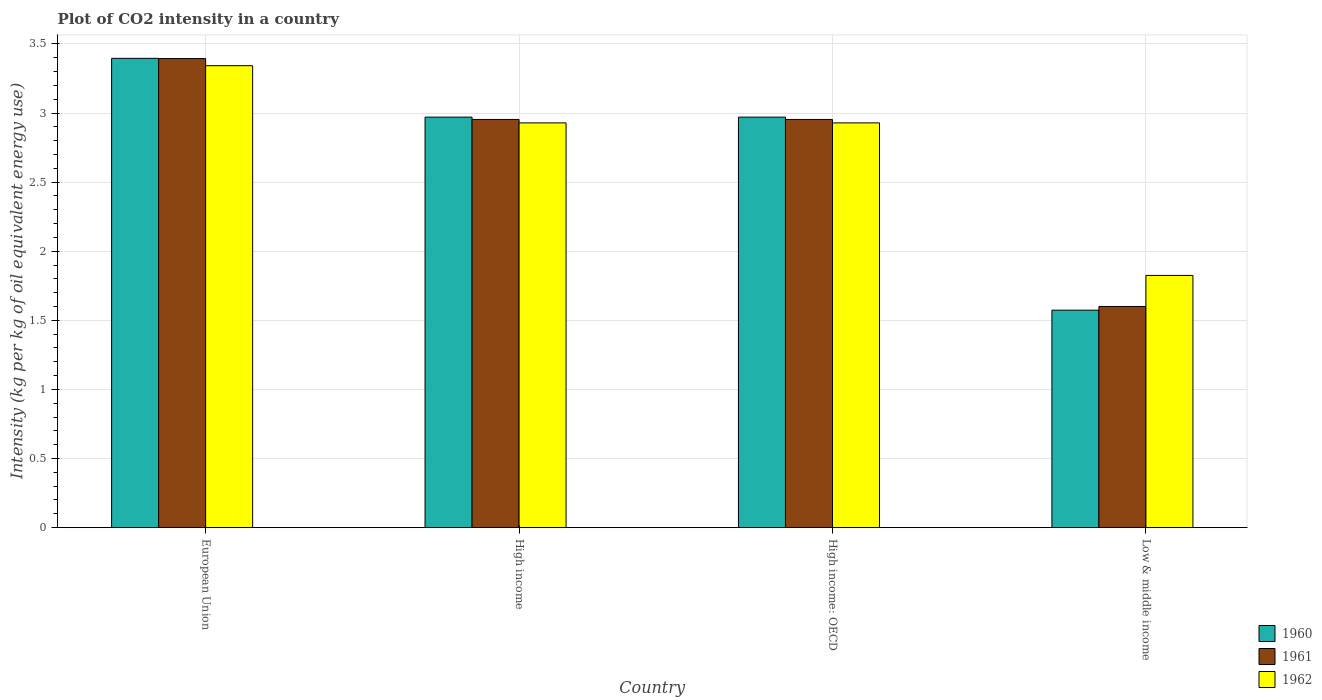How many groups of bars are there?
Your answer should be compact. 4. Are the number of bars per tick equal to the number of legend labels?
Offer a terse response. Yes. Are the number of bars on each tick of the X-axis equal?
Provide a short and direct response. Yes. How many bars are there on the 4th tick from the right?
Give a very brief answer. 3. What is the CO2 intensity in in 1962 in Low & middle income?
Provide a succinct answer. 1.82. Across all countries, what is the maximum CO2 intensity in in 1962?
Your answer should be compact. 3.34. Across all countries, what is the minimum CO2 intensity in in 1962?
Keep it short and to the point. 1.82. What is the total CO2 intensity in in 1960 in the graph?
Ensure brevity in your answer.  10.91. What is the difference between the CO2 intensity in in 1961 in European Union and that in High income?
Provide a succinct answer. 0.44. What is the difference between the CO2 intensity in in 1961 in High income and the CO2 intensity in in 1960 in European Union?
Give a very brief answer. -0.44. What is the average CO2 intensity in in 1960 per country?
Give a very brief answer. 2.73. What is the difference between the CO2 intensity in of/in 1960 and CO2 intensity in of/in 1961 in European Union?
Offer a terse response. 0. What is the ratio of the CO2 intensity in in 1962 in European Union to that in High income?
Offer a very short reply. 1.14. Is the difference between the CO2 intensity in in 1960 in European Union and High income: OECD greater than the difference between the CO2 intensity in in 1961 in European Union and High income: OECD?
Your response must be concise. No. What is the difference between the highest and the second highest CO2 intensity in in 1960?
Your answer should be very brief. -0.43. What is the difference between the highest and the lowest CO2 intensity in in 1960?
Make the answer very short. 1.82. Are all the bars in the graph horizontal?
Give a very brief answer. No. How many countries are there in the graph?
Give a very brief answer. 4. Does the graph contain any zero values?
Your answer should be compact. No. How many legend labels are there?
Your answer should be very brief. 3. What is the title of the graph?
Offer a very short reply. Plot of CO2 intensity in a country. Does "1980" appear as one of the legend labels in the graph?
Offer a terse response. No. What is the label or title of the X-axis?
Make the answer very short. Country. What is the label or title of the Y-axis?
Your answer should be very brief. Intensity (kg per kg of oil equivalent energy use). What is the Intensity (kg per kg of oil equivalent energy use) of 1960 in European Union?
Ensure brevity in your answer.  3.4. What is the Intensity (kg per kg of oil equivalent energy use) of 1961 in European Union?
Provide a short and direct response. 3.39. What is the Intensity (kg per kg of oil equivalent energy use) of 1962 in European Union?
Provide a short and direct response. 3.34. What is the Intensity (kg per kg of oil equivalent energy use) in 1960 in High income?
Your answer should be very brief. 2.97. What is the Intensity (kg per kg of oil equivalent energy use) in 1961 in High income?
Provide a succinct answer. 2.95. What is the Intensity (kg per kg of oil equivalent energy use) of 1962 in High income?
Provide a succinct answer. 2.93. What is the Intensity (kg per kg of oil equivalent energy use) of 1960 in High income: OECD?
Ensure brevity in your answer.  2.97. What is the Intensity (kg per kg of oil equivalent energy use) in 1961 in High income: OECD?
Make the answer very short. 2.95. What is the Intensity (kg per kg of oil equivalent energy use) in 1962 in High income: OECD?
Offer a very short reply. 2.93. What is the Intensity (kg per kg of oil equivalent energy use) in 1960 in Low & middle income?
Give a very brief answer. 1.57. What is the Intensity (kg per kg of oil equivalent energy use) in 1961 in Low & middle income?
Make the answer very short. 1.6. What is the Intensity (kg per kg of oil equivalent energy use) of 1962 in Low & middle income?
Ensure brevity in your answer.  1.82. Across all countries, what is the maximum Intensity (kg per kg of oil equivalent energy use) of 1960?
Provide a succinct answer. 3.4. Across all countries, what is the maximum Intensity (kg per kg of oil equivalent energy use) of 1961?
Keep it short and to the point. 3.39. Across all countries, what is the maximum Intensity (kg per kg of oil equivalent energy use) in 1962?
Provide a short and direct response. 3.34. Across all countries, what is the minimum Intensity (kg per kg of oil equivalent energy use) in 1960?
Your answer should be very brief. 1.57. Across all countries, what is the minimum Intensity (kg per kg of oil equivalent energy use) in 1961?
Make the answer very short. 1.6. Across all countries, what is the minimum Intensity (kg per kg of oil equivalent energy use) in 1962?
Provide a short and direct response. 1.82. What is the total Intensity (kg per kg of oil equivalent energy use) in 1960 in the graph?
Make the answer very short. 10.91. What is the total Intensity (kg per kg of oil equivalent energy use) in 1961 in the graph?
Provide a succinct answer. 10.9. What is the total Intensity (kg per kg of oil equivalent energy use) in 1962 in the graph?
Provide a short and direct response. 11.03. What is the difference between the Intensity (kg per kg of oil equivalent energy use) of 1960 in European Union and that in High income?
Your answer should be compact. 0.43. What is the difference between the Intensity (kg per kg of oil equivalent energy use) of 1961 in European Union and that in High income?
Ensure brevity in your answer.  0.44. What is the difference between the Intensity (kg per kg of oil equivalent energy use) of 1962 in European Union and that in High income?
Your response must be concise. 0.41. What is the difference between the Intensity (kg per kg of oil equivalent energy use) in 1960 in European Union and that in High income: OECD?
Give a very brief answer. 0.43. What is the difference between the Intensity (kg per kg of oil equivalent energy use) of 1961 in European Union and that in High income: OECD?
Offer a terse response. 0.44. What is the difference between the Intensity (kg per kg of oil equivalent energy use) in 1962 in European Union and that in High income: OECD?
Ensure brevity in your answer.  0.41. What is the difference between the Intensity (kg per kg of oil equivalent energy use) of 1960 in European Union and that in Low & middle income?
Your answer should be very brief. 1.82. What is the difference between the Intensity (kg per kg of oil equivalent energy use) in 1961 in European Union and that in Low & middle income?
Offer a very short reply. 1.79. What is the difference between the Intensity (kg per kg of oil equivalent energy use) in 1962 in European Union and that in Low & middle income?
Make the answer very short. 1.52. What is the difference between the Intensity (kg per kg of oil equivalent energy use) in 1960 in High income and that in Low & middle income?
Your response must be concise. 1.4. What is the difference between the Intensity (kg per kg of oil equivalent energy use) in 1961 in High income and that in Low & middle income?
Your answer should be compact. 1.35. What is the difference between the Intensity (kg per kg of oil equivalent energy use) in 1962 in High income and that in Low & middle income?
Ensure brevity in your answer.  1.1. What is the difference between the Intensity (kg per kg of oil equivalent energy use) in 1960 in High income: OECD and that in Low & middle income?
Your answer should be compact. 1.4. What is the difference between the Intensity (kg per kg of oil equivalent energy use) of 1961 in High income: OECD and that in Low & middle income?
Your answer should be compact. 1.35. What is the difference between the Intensity (kg per kg of oil equivalent energy use) in 1962 in High income: OECD and that in Low & middle income?
Provide a succinct answer. 1.1. What is the difference between the Intensity (kg per kg of oil equivalent energy use) in 1960 in European Union and the Intensity (kg per kg of oil equivalent energy use) in 1961 in High income?
Give a very brief answer. 0.44. What is the difference between the Intensity (kg per kg of oil equivalent energy use) in 1960 in European Union and the Intensity (kg per kg of oil equivalent energy use) in 1962 in High income?
Give a very brief answer. 0.47. What is the difference between the Intensity (kg per kg of oil equivalent energy use) of 1961 in European Union and the Intensity (kg per kg of oil equivalent energy use) of 1962 in High income?
Make the answer very short. 0.47. What is the difference between the Intensity (kg per kg of oil equivalent energy use) in 1960 in European Union and the Intensity (kg per kg of oil equivalent energy use) in 1961 in High income: OECD?
Provide a succinct answer. 0.44. What is the difference between the Intensity (kg per kg of oil equivalent energy use) of 1960 in European Union and the Intensity (kg per kg of oil equivalent energy use) of 1962 in High income: OECD?
Your answer should be compact. 0.47. What is the difference between the Intensity (kg per kg of oil equivalent energy use) of 1961 in European Union and the Intensity (kg per kg of oil equivalent energy use) of 1962 in High income: OECD?
Provide a succinct answer. 0.47. What is the difference between the Intensity (kg per kg of oil equivalent energy use) in 1960 in European Union and the Intensity (kg per kg of oil equivalent energy use) in 1961 in Low & middle income?
Provide a short and direct response. 1.8. What is the difference between the Intensity (kg per kg of oil equivalent energy use) in 1960 in European Union and the Intensity (kg per kg of oil equivalent energy use) in 1962 in Low & middle income?
Offer a very short reply. 1.57. What is the difference between the Intensity (kg per kg of oil equivalent energy use) of 1961 in European Union and the Intensity (kg per kg of oil equivalent energy use) of 1962 in Low & middle income?
Provide a succinct answer. 1.57. What is the difference between the Intensity (kg per kg of oil equivalent energy use) of 1960 in High income and the Intensity (kg per kg of oil equivalent energy use) of 1961 in High income: OECD?
Provide a short and direct response. 0.02. What is the difference between the Intensity (kg per kg of oil equivalent energy use) of 1960 in High income and the Intensity (kg per kg of oil equivalent energy use) of 1962 in High income: OECD?
Give a very brief answer. 0.04. What is the difference between the Intensity (kg per kg of oil equivalent energy use) of 1961 in High income and the Intensity (kg per kg of oil equivalent energy use) of 1962 in High income: OECD?
Offer a very short reply. 0.02. What is the difference between the Intensity (kg per kg of oil equivalent energy use) in 1960 in High income and the Intensity (kg per kg of oil equivalent energy use) in 1961 in Low & middle income?
Your answer should be compact. 1.37. What is the difference between the Intensity (kg per kg of oil equivalent energy use) in 1960 in High income and the Intensity (kg per kg of oil equivalent energy use) in 1962 in Low & middle income?
Your answer should be very brief. 1.15. What is the difference between the Intensity (kg per kg of oil equivalent energy use) in 1961 in High income and the Intensity (kg per kg of oil equivalent energy use) in 1962 in Low & middle income?
Offer a very short reply. 1.13. What is the difference between the Intensity (kg per kg of oil equivalent energy use) in 1960 in High income: OECD and the Intensity (kg per kg of oil equivalent energy use) in 1961 in Low & middle income?
Provide a short and direct response. 1.37. What is the difference between the Intensity (kg per kg of oil equivalent energy use) of 1960 in High income: OECD and the Intensity (kg per kg of oil equivalent energy use) of 1962 in Low & middle income?
Your answer should be compact. 1.15. What is the difference between the Intensity (kg per kg of oil equivalent energy use) in 1961 in High income: OECD and the Intensity (kg per kg of oil equivalent energy use) in 1962 in Low & middle income?
Keep it short and to the point. 1.13. What is the average Intensity (kg per kg of oil equivalent energy use) of 1960 per country?
Make the answer very short. 2.73. What is the average Intensity (kg per kg of oil equivalent energy use) of 1961 per country?
Your response must be concise. 2.73. What is the average Intensity (kg per kg of oil equivalent energy use) in 1962 per country?
Provide a succinct answer. 2.76. What is the difference between the Intensity (kg per kg of oil equivalent energy use) in 1960 and Intensity (kg per kg of oil equivalent energy use) in 1961 in European Union?
Ensure brevity in your answer.  0. What is the difference between the Intensity (kg per kg of oil equivalent energy use) of 1960 and Intensity (kg per kg of oil equivalent energy use) of 1962 in European Union?
Your answer should be very brief. 0.05. What is the difference between the Intensity (kg per kg of oil equivalent energy use) in 1961 and Intensity (kg per kg of oil equivalent energy use) in 1962 in European Union?
Give a very brief answer. 0.05. What is the difference between the Intensity (kg per kg of oil equivalent energy use) of 1960 and Intensity (kg per kg of oil equivalent energy use) of 1961 in High income?
Your answer should be compact. 0.02. What is the difference between the Intensity (kg per kg of oil equivalent energy use) in 1960 and Intensity (kg per kg of oil equivalent energy use) in 1962 in High income?
Offer a terse response. 0.04. What is the difference between the Intensity (kg per kg of oil equivalent energy use) of 1961 and Intensity (kg per kg of oil equivalent energy use) of 1962 in High income?
Your answer should be very brief. 0.02. What is the difference between the Intensity (kg per kg of oil equivalent energy use) in 1960 and Intensity (kg per kg of oil equivalent energy use) in 1961 in High income: OECD?
Offer a very short reply. 0.02. What is the difference between the Intensity (kg per kg of oil equivalent energy use) of 1960 and Intensity (kg per kg of oil equivalent energy use) of 1962 in High income: OECD?
Provide a short and direct response. 0.04. What is the difference between the Intensity (kg per kg of oil equivalent energy use) of 1961 and Intensity (kg per kg of oil equivalent energy use) of 1962 in High income: OECD?
Your response must be concise. 0.02. What is the difference between the Intensity (kg per kg of oil equivalent energy use) in 1960 and Intensity (kg per kg of oil equivalent energy use) in 1961 in Low & middle income?
Keep it short and to the point. -0.03. What is the difference between the Intensity (kg per kg of oil equivalent energy use) in 1960 and Intensity (kg per kg of oil equivalent energy use) in 1962 in Low & middle income?
Your answer should be very brief. -0.25. What is the difference between the Intensity (kg per kg of oil equivalent energy use) of 1961 and Intensity (kg per kg of oil equivalent energy use) of 1962 in Low & middle income?
Offer a terse response. -0.22. What is the ratio of the Intensity (kg per kg of oil equivalent energy use) of 1960 in European Union to that in High income?
Provide a short and direct response. 1.14. What is the ratio of the Intensity (kg per kg of oil equivalent energy use) of 1961 in European Union to that in High income?
Offer a terse response. 1.15. What is the ratio of the Intensity (kg per kg of oil equivalent energy use) in 1962 in European Union to that in High income?
Ensure brevity in your answer.  1.14. What is the ratio of the Intensity (kg per kg of oil equivalent energy use) of 1960 in European Union to that in High income: OECD?
Ensure brevity in your answer.  1.14. What is the ratio of the Intensity (kg per kg of oil equivalent energy use) in 1961 in European Union to that in High income: OECD?
Make the answer very short. 1.15. What is the ratio of the Intensity (kg per kg of oil equivalent energy use) in 1962 in European Union to that in High income: OECD?
Offer a terse response. 1.14. What is the ratio of the Intensity (kg per kg of oil equivalent energy use) in 1960 in European Union to that in Low & middle income?
Offer a very short reply. 2.16. What is the ratio of the Intensity (kg per kg of oil equivalent energy use) in 1961 in European Union to that in Low & middle income?
Your answer should be very brief. 2.12. What is the ratio of the Intensity (kg per kg of oil equivalent energy use) of 1962 in European Union to that in Low & middle income?
Make the answer very short. 1.83. What is the ratio of the Intensity (kg per kg of oil equivalent energy use) of 1960 in High income to that in High income: OECD?
Ensure brevity in your answer.  1. What is the ratio of the Intensity (kg per kg of oil equivalent energy use) in 1960 in High income to that in Low & middle income?
Keep it short and to the point. 1.89. What is the ratio of the Intensity (kg per kg of oil equivalent energy use) in 1961 in High income to that in Low & middle income?
Your answer should be compact. 1.85. What is the ratio of the Intensity (kg per kg of oil equivalent energy use) in 1962 in High income to that in Low & middle income?
Your response must be concise. 1.6. What is the ratio of the Intensity (kg per kg of oil equivalent energy use) of 1960 in High income: OECD to that in Low & middle income?
Offer a very short reply. 1.89. What is the ratio of the Intensity (kg per kg of oil equivalent energy use) of 1961 in High income: OECD to that in Low & middle income?
Make the answer very short. 1.85. What is the ratio of the Intensity (kg per kg of oil equivalent energy use) of 1962 in High income: OECD to that in Low & middle income?
Provide a succinct answer. 1.6. What is the difference between the highest and the second highest Intensity (kg per kg of oil equivalent energy use) of 1960?
Your answer should be compact. 0.43. What is the difference between the highest and the second highest Intensity (kg per kg of oil equivalent energy use) in 1961?
Your response must be concise. 0.44. What is the difference between the highest and the second highest Intensity (kg per kg of oil equivalent energy use) of 1962?
Your answer should be very brief. 0.41. What is the difference between the highest and the lowest Intensity (kg per kg of oil equivalent energy use) in 1960?
Offer a very short reply. 1.82. What is the difference between the highest and the lowest Intensity (kg per kg of oil equivalent energy use) in 1961?
Your response must be concise. 1.79. What is the difference between the highest and the lowest Intensity (kg per kg of oil equivalent energy use) of 1962?
Your response must be concise. 1.52. 